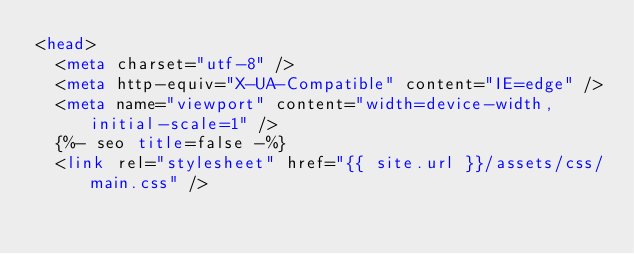<code> <loc_0><loc_0><loc_500><loc_500><_HTML_><head>
  <meta charset="utf-8" />
  <meta http-equiv="X-UA-Compatible" content="IE=edge" />
  <meta name="viewport" content="width=device-width, initial-scale=1" />
  {%- seo title=false -%}
  <link rel="stylesheet" href="{{ site.url }}/assets/css/main.css" /></code> 